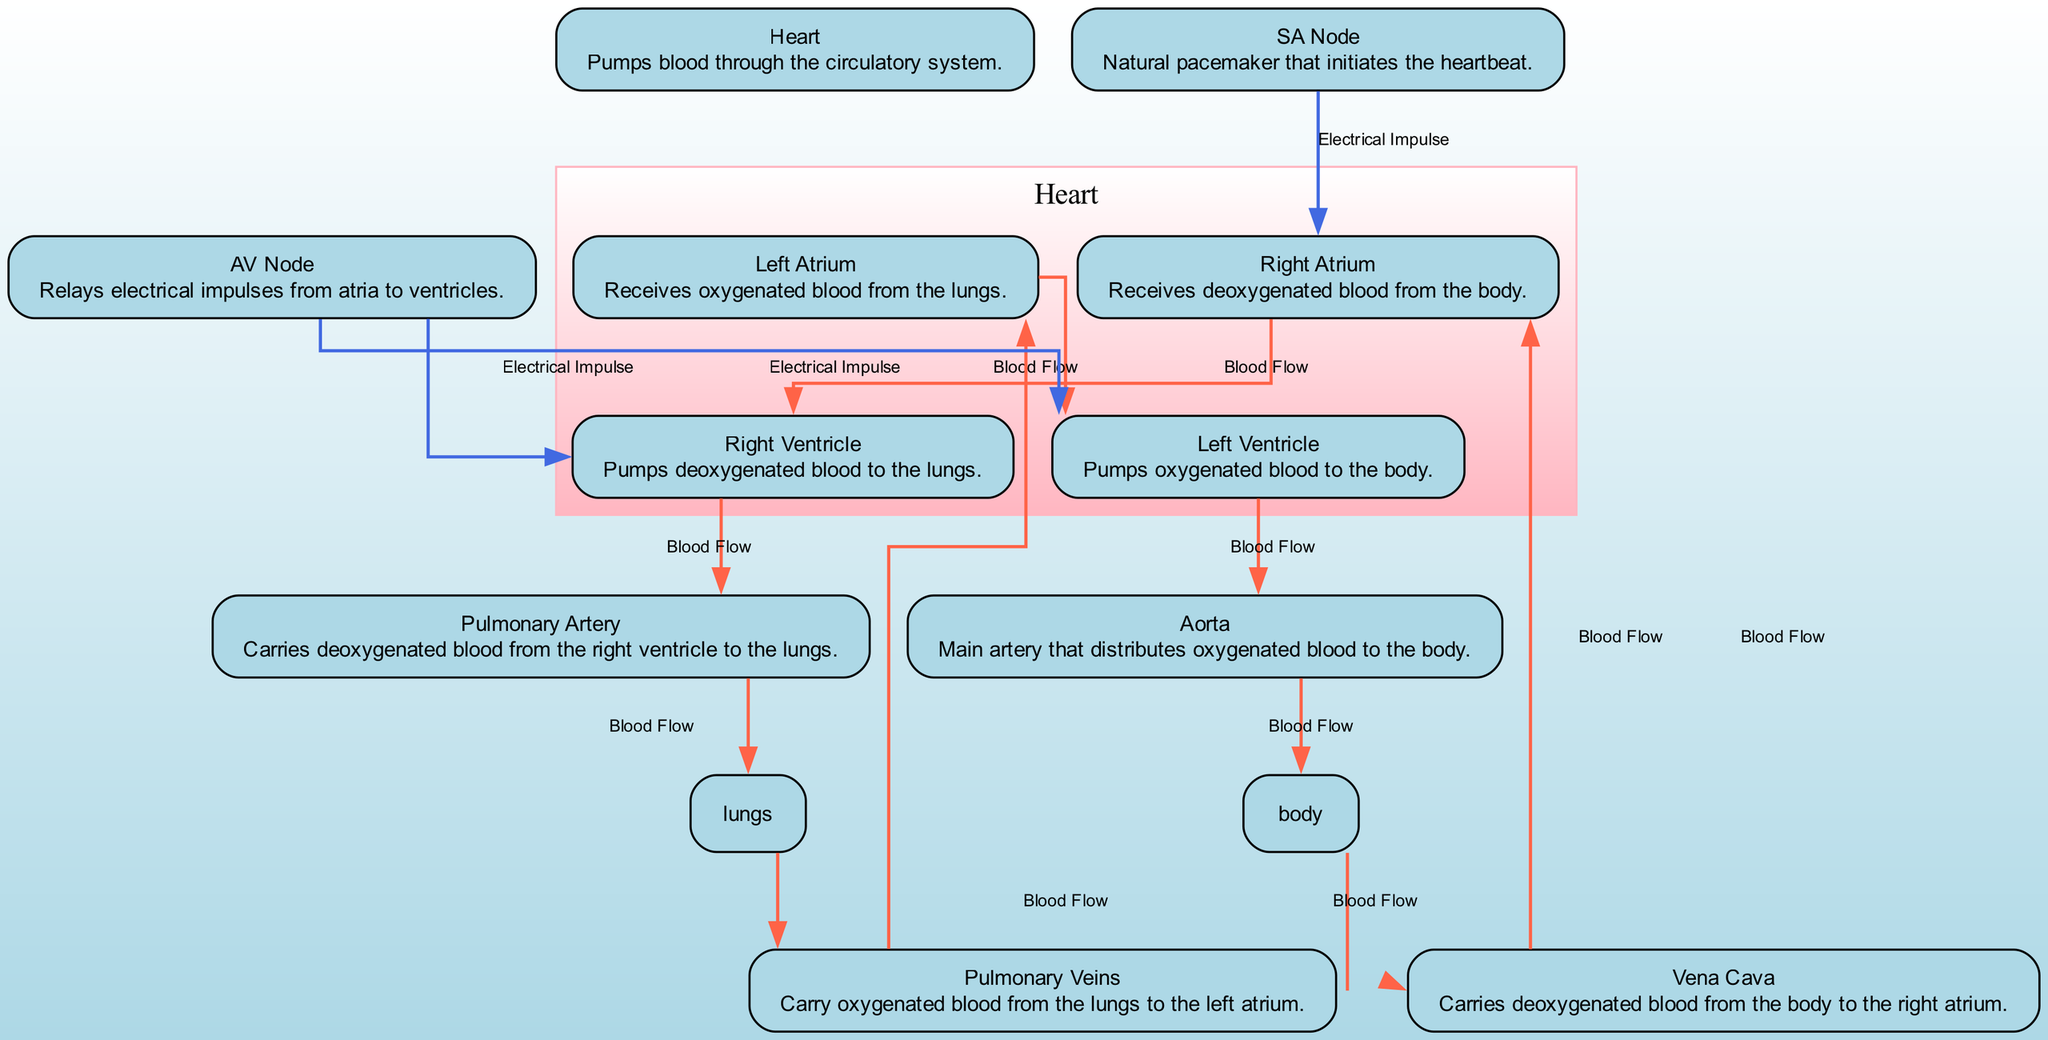What is the main function of the heart? The diagram describes the heart as the node that "Pumps blood through the circulatory system." Thus, the primary function indicated is to pump blood.
Answer: Pumps blood How many chambers are in the heart as represented in the diagram? The diagram shows four chambers represented as nodes: Right Atrium, Right Ventricle, Left Atrium, and Left Ventricle. Counting these nodes gives a total of four chambers.
Answer: Four What carries deoxygenated blood from the body to the right atrium? The diagram indicates that the "Vena Cava" carries deoxygenated blood from the body to the right atrium. Thus, the answer focuses on the specific pathway mentioned.
Answer: Vena Cava Which node serves as the natural pacemaker of the heart? In the diagram, the "SA Node" is labeled as the natural pacemaker initiating the heartbeat. This identifies the specific component responsible for this function.
Answer: SA Node How does oxygenated blood flow from the lungs to the left atrium? The diagram illustrates that oxygenated blood moves from the "Lungs" to the "Pulmonary Veins," and then from the "Pulmonary Veins" to the "Left Atrium." This sequential connection highlights the pathway for oxygenated blood.
Answer: Pulmonary Veins to Left Atrium Which chamber of the heart pumps deoxygenated blood to the lungs? The diagram identifies the "Right Ventricle" as the chamber responsible for pumping deoxygenated blood to the lungs. This can be found by following the flow from the right atrium to the right ventricle and then to the pulmonary artery.
Answer: Right Ventricle What is the relationship between the AV Node and the Left Ventricle? The AV Node relays electrical impulses to the Left Ventricle, as shown by the directed edge labeled "Electrical Impulse" connecting these two nodes. This indicates the function of the AV Node in heart regulation.
Answer: Relays electrical impulses How many nodes represent the flow of blood from the heart to the body? The flow of blood from the heart to the body starts from the Left Ventricle, goes to the Aorta, and finally to the Body, which totals three nodes in this pathway.
Answer: Three What type of blood is carried by the pulmonary artery? The diagram specifies that the "Pulmonary Artery" carries deoxygenated blood from the right ventricle to the lungs, thus directly identifying the type of blood transported.
Answer: Deoxygenated blood Which node receives oxygenated blood from the lungs? According to the diagram, the "Left Atrium" receives oxygenated blood brought in by the pulmonary veins from the lungs. This clearly points out the receiving chamber for oxygen-rich blood.
Answer: Left Atrium 